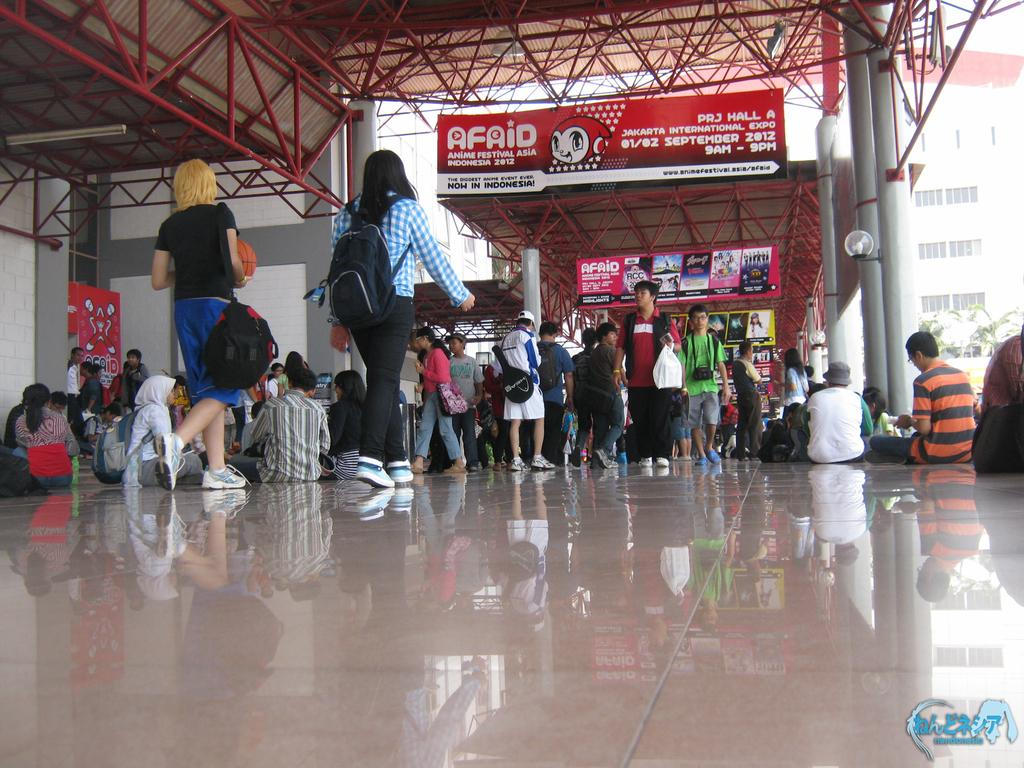What are the two people in the image doing? The two people in the image are walking. What can be seen on the sides of the road in the image? There are hoardings visible in the image. How many people are present in the image? There are people in the image, including some who are sitting. What type of structure can be seen in the image? There is a building with windows in the image. What is attached to the pole in the image? A light is attached to a pole in the image. What type of shelter is present in the image? There is an open shed in the image. How many windows are visible on the visitor in the image? There is no visitor present in the image, and therefore no windows can be observed on a visitor. What type of hole can be seen in the image? There is no hole present in the image. 